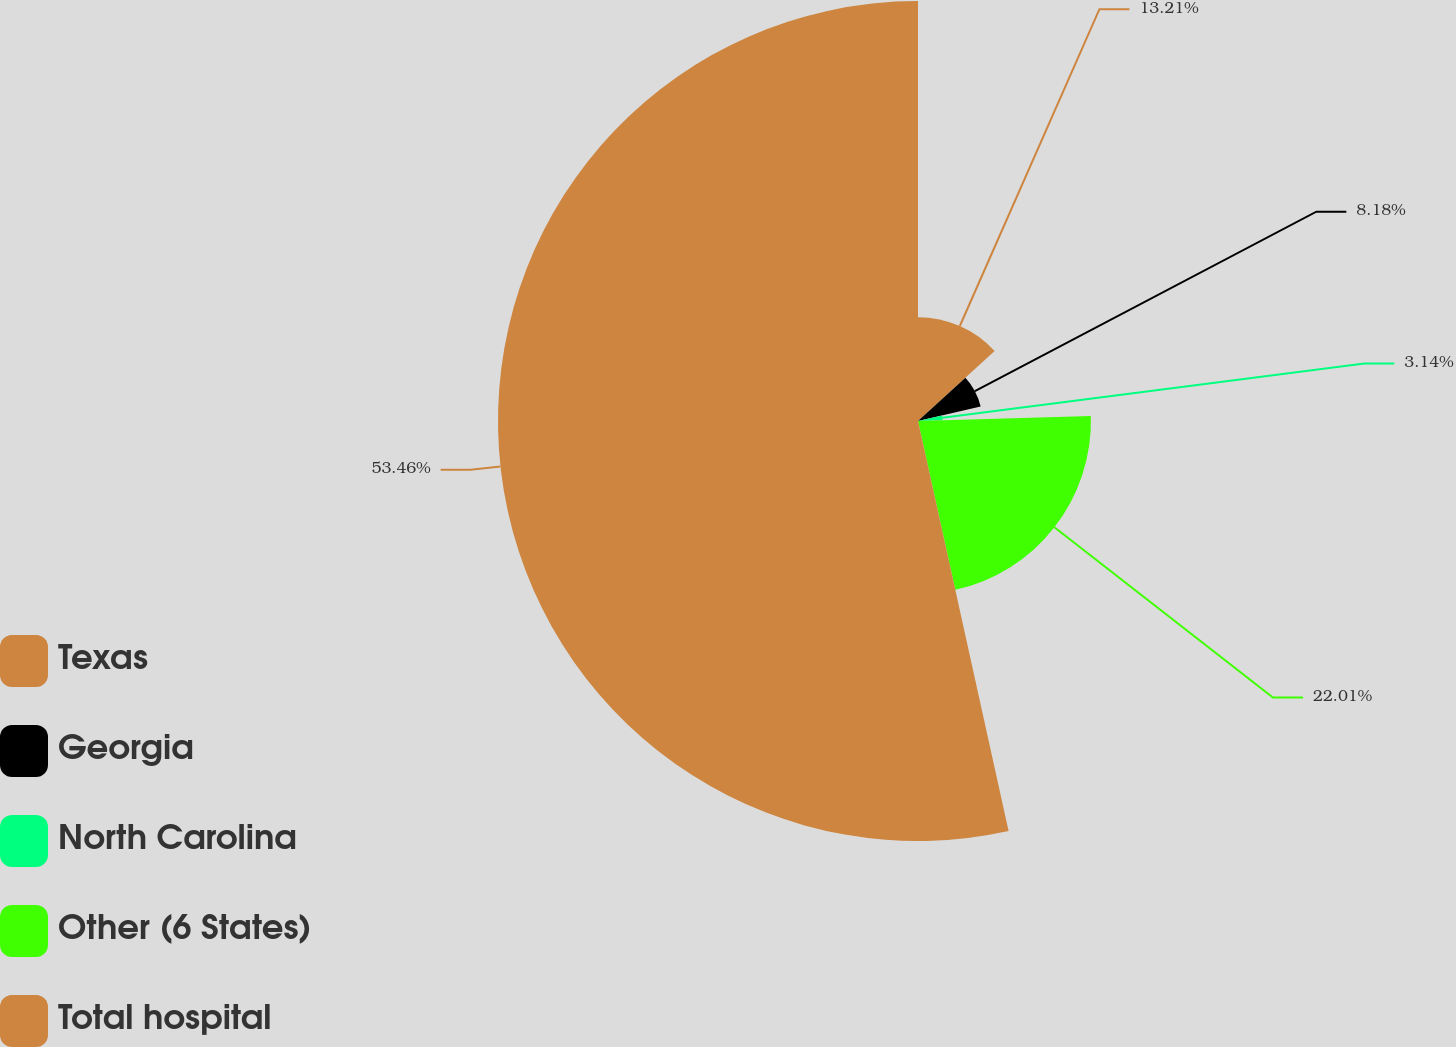<chart> <loc_0><loc_0><loc_500><loc_500><pie_chart><fcel>Texas<fcel>Georgia<fcel>North Carolina<fcel>Other (6 States)<fcel>Total hospital<nl><fcel>13.21%<fcel>8.18%<fcel>3.14%<fcel>22.01%<fcel>53.46%<nl></chart> 